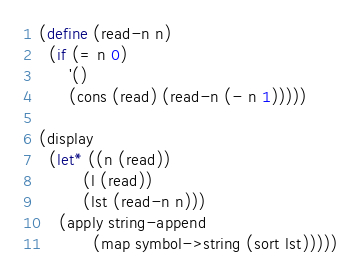<code> <loc_0><loc_0><loc_500><loc_500><_Scheme_>(define (read-n n)
  (if (= n 0)
      '()
      (cons (read) (read-n (- n 1)))))

(display
  (let* ((n (read))
         (l (read))
         (lst (read-n n)))
    (apply string-append
           (map symbol->string (sort lst)))))
</code> 